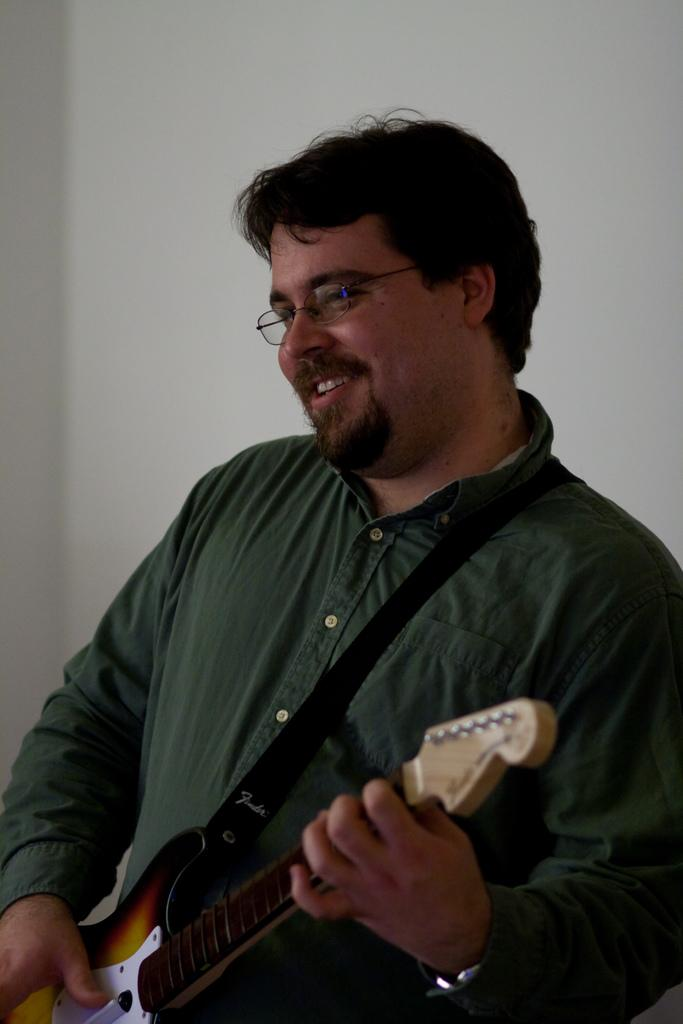What is the man in the image doing? The man is playing the guitar. What object is the man holding in the image? The man is holding a guitar. What can be seen on the man's face in the image? The man is wearing spectacles and smiling. What is visible in the background of the image? There is a wall in the background of the image. Can the man in the image push a can down the street? There is no can or street present in the image, so it is not possible to determine if the man can push a can down the street. 